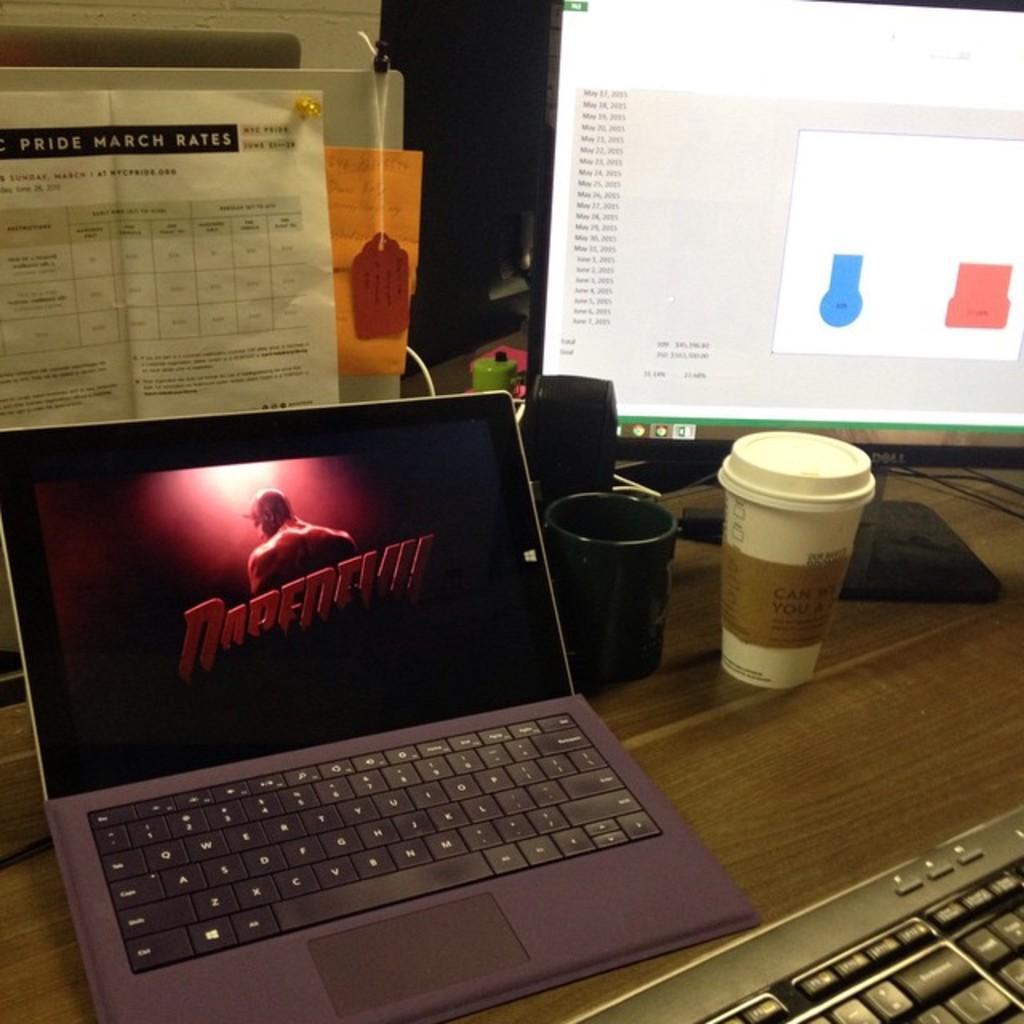Could you give a brief overview of what you see in this image? In the image on the wooden surface there is a laptop, keyboard, monitor, black cup and bottle. Behind the laptop there are few papers attached to the wall and also there is a tag hanging to it. 